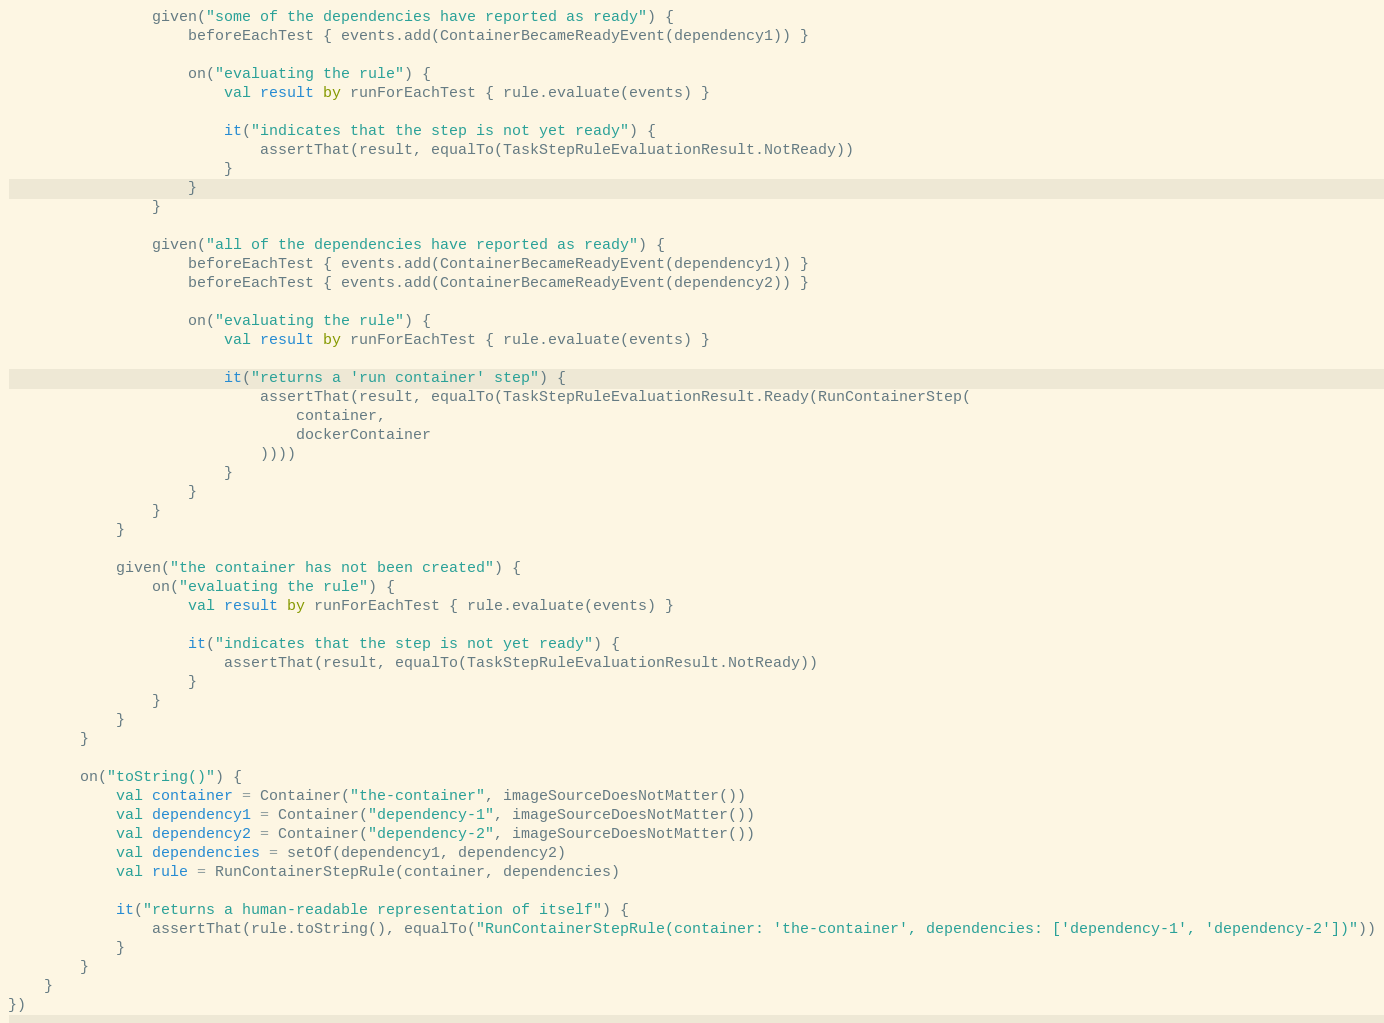Convert code to text. <code><loc_0><loc_0><loc_500><loc_500><_Kotlin_>
                given("some of the dependencies have reported as ready") {
                    beforeEachTest { events.add(ContainerBecameReadyEvent(dependency1)) }

                    on("evaluating the rule") {
                        val result by runForEachTest { rule.evaluate(events) }

                        it("indicates that the step is not yet ready") {
                            assertThat(result, equalTo(TaskStepRuleEvaluationResult.NotReady))
                        }
                    }
                }

                given("all of the dependencies have reported as ready") {
                    beforeEachTest { events.add(ContainerBecameReadyEvent(dependency1)) }
                    beforeEachTest { events.add(ContainerBecameReadyEvent(dependency2)) }

                    on("evaluating the rule") {
                        val result by runForEachTest { rule.evaluate(events) }

                        it("returns a 'run container' step") {
                            assertThat(result, equalTo(TaskStepRuleEvaluationResult.Ready(RunContainerStep(
                                container,
                                dockerContainer
                            ))))
                        }
                    }
                }
            }

            given("the container has not been created") {
                on("evaluating the rule") {
                    val result by runForEachTest { rule.evaluate(events) }

                    it("indicates that the step is not yet ready") {
                        assertThat(result, equalTo(TaskStepRuleEvaluationResult.NotReady))
                    }
                }
            }
        }

        on("toString()") {
            val container = Container("the-container", imageSourceDoesNotMatter())
            val dependency1 = Container("dependency-1", imageSourceDoesNotMatter())
            val dependency2 = Container("dependency-2", imageSourceDoesNotMatter())
            val dependencies = setOf(dependency1, dependency2)
            val rule = RunContainerStepRule(container, dependencies)

            it("returns a human-readable representation of itself") {
                assertThat(rule.toString(), equalTo("RunContainerStepRule(container: 'the-container', dependencies: ['dependency-1', 'dependency-2'])"))
            }
        }
    }
})
</code> 